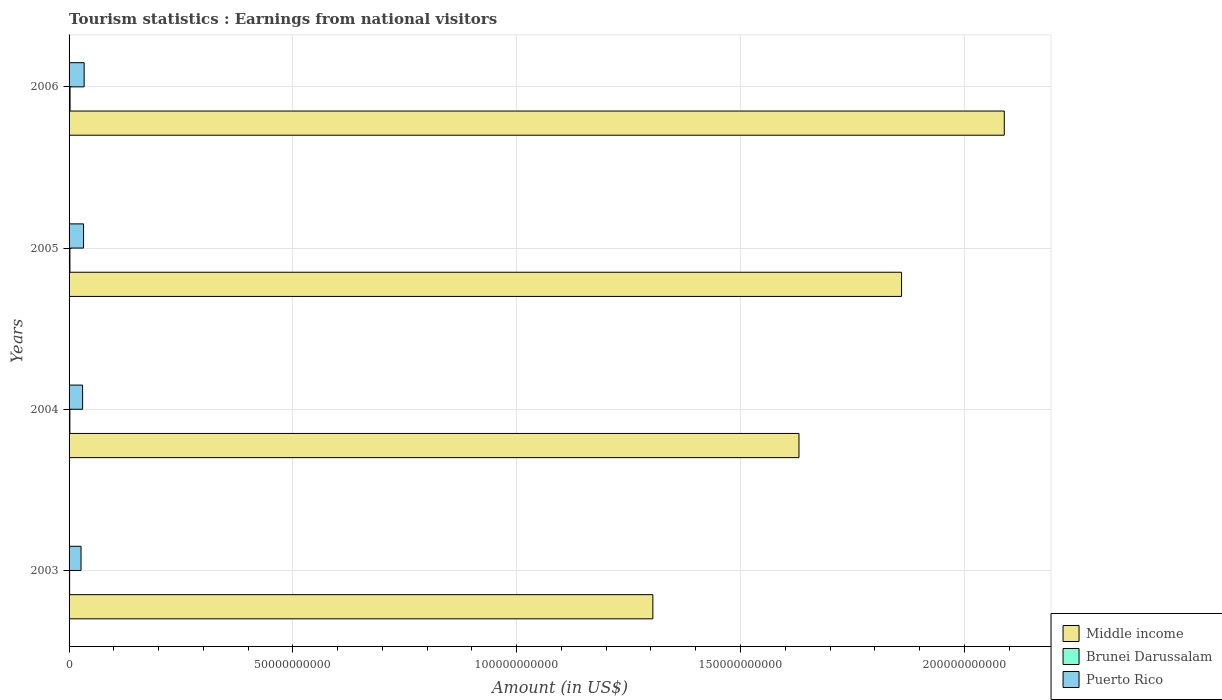How many different coloured bars are there?
Make the answer very short. 3. Are the number of bars per tick equal to the number of legend labels?
Your answer should be compact. Yes. Are the number of bars on each tick of the Y-axis equal?
Offer a terse response. Yes. What is the earnings from national visitors in Middle income in 2004?
Your response must be concise. 1.63e+11. Across all years, what is the maximum earnings from national visitors in Middle income?
Ensure brevity in your answer.  2.09e+11. Across all years, what is the minimum earnings from national visitors in Brunei Darussalam?
Give a very brief answer. 1.24e+08. What is the total earnings from national visitors in Puerto Rico in the graph?
Your answer should be very brief. 1.23e+1. What is the difference between the earnings from national visitors in Middle income in 2004 and that in 2006?
Your answer should be very brief. -4.59e+1. What is the difference between the earnings from national visitors in Puerto Rico in 2006 and the earnings from national visitors in Middle income in 2005?
Provide a succinct answer. -1.83e+11. What is the average earnings from national visitors in Brunei Darussalam per year?
Provide a succinct answer. 1.80e+08. In the year 2003, what is the difference between the earnings from national visitors in Brunei Darussalam and earnings from national visitors in Middle income?
Your answer should be very brief. -1.30e+11. In how many years, is the earnings from national visitors in Middle income greater than 160000000000 US$?
Give a very brief answer. 3. What is the ratio of the earnings from national visitors in Brunei Darussalam in 2004 to that in 2006?
Offer a very short reply. 0.81. Is the earnings from national visitors in Puerto Rico in 2003 less than that in 2005?
Give a very brief answer. Yes. What is the difference between the highest and the second highest earnings from national visitors in Puerto Rico?
Provide a short and direct response. 1.30e+08. What is the difference between the highest and the lowest earnings from national visitors in Brunei Darussalam?
Offer a terse response. 1.00e+08. In how many years, is the earnings from national visitors in Middle income greater than the average earnings from national visitors in Middle income taken over all years?
Offer a terse response. 2. Is the sum of the earnings from national visitors in Puerto Rico in 2004 and 2006 greater than the maximum earnings from national visitors in Brunei Darussalam across all years?
Provide a short and direct response. Yes. What does the 1st bar from the top in 2004 represents?
Keep it short and to the point. Puerto Rico. What does the 2nd bar from the bottom in 2003 represents?
Give a very brief answer. Brunei Darussalam. How many bars are there?
Offer a terse response. 12. Are all the bars in the graph horizontal?
Your answer should be compact. Yes. How many years are there in the graph?
Make the answer very short. 4. Are the values on the major ticks of X-axis written in scientific E-notation?
Offer a terse response. No. Does the graph contain any zero values?
Ensure brevity in your answer.  No. Does the graph contain grids?
Your answer should be compact. Yes. Where does the legend appear in the graph?
Keep it short and to the point. Bottom right. How many legend labels are there?
Your answer should be very brief. 3. How are the legend labels stacked?
Offer a terse response. Vertical. What is the title of the graph?
Give a very brief answer. Tourism statistics : Earnings from national visitors. Does "Philippines" appear as one of the legend labels in the graph?
Ensure brevity in your answer.  No. What is the label or title of the Y-axis?
Make the answer very short. Years. What is the Amount (in US$) in Middle income in 2003?
Offer a very short reply. 1.30e+11. What is the Amount (in US$) in Brunei Darussalam in 2003?
Keep it short and to the point. 1.24e+08. What is the Amount (in US$) of Puerto Rico in 2003?
Your answer should be very brief. 2.68e+09. What is the Amount (in US$) in Middle income in 2004?
Your answer should be very brief. 1.63e+11. What is the Amount (in US$) of Brunei Darussalam in 2004?
Ensure brevity in your answer.  1.81e+08. What is the Amount (in US$) in Puerto Rico in 2004?
Offer a very short reply. 3.02e+09. What is the Amount (in US$) in Middle income in 2005?
Keep it short and to the point. 1.86e+11. What is the Amount (in US$) in Brunei Darussalam in 2005?
Offer a very short reply. 1.91e+08. What is the Amount (in US$) in Puerto Rico in 2005?
Offer a terse response. 3.24e+09. What is the Amount (in US$) of Middle income in 2006?
Your response must be concise. 2.09e+11. What is the Amount (in US$) in Brunei Darussalam in 2006?
Give a very brief answer. 2.24e+08. What is the Amount (in US$) in Puerto Rico in 2006?
Offer a very short reply. 3.37e+09. Across all years, what is the maximum Amount (in US$) in Middle income?
Ensure brevity in your answer.  2.09e+11. Across all years, what is the maximum Amount (in US$) of Brunei Darussalam?
Make the answer very short. 2.24e+08. Across all years, what is the maximum Amount (in US$) of Puerto Rico?
Your answer should be very brief. 3.37e+09. Across all years, what is the minimum Amount (in US$) of Middle income?
Your answer should be compact. 1.30e+11. Across all years, what is the minimum Amount (in US$) of Brunei Darussalam?
Give a very brief answer. 1.24e+08. Across all years, what is the minimum Amount (in US$) of Puerto Rico?
Make the answer very short. 2.68e+09. What is the total Amount (in US$) of Middle income in the graph?
Your answer should be compact. 6.88e+11. What is the total Amount (in US$) in Brunei Darussalam in the graph?
Your answer should be very brief. 7.20e+08. What is the total Amount (in US$) of Puerto Rico in the graph?
Keep it short and to the point. 1.23e+1. What is the difference between the Amount (in US$) of Middle income in 2003 and that in 2004?
Provide a succinct answer. -3.26e+1. What is the difference between the Amount (in US$) of Brunei Darussalam in 2003 and that in 2004?
Offer a terse response. -5.70e+07. What is the difference between the Amount (in US$) in Puerto Rico in 2003 and that in 2004?
Offer a terse response. -3.47e+08. What is the difference between the Amount (in US$) of Middle income in 2003 and that in 2005?
Your response must be concise. -5.56e+1. What is the difference between the Amount (in US$) of Brunei Darussalam in 2003 and that in 2005?
Your answer should be compact. -6.70e+07. What is the difference between the Amount (in US$) of Puerto Rico in 2003 and that in 2005?
Keep it short and to the point. -5.62e+08. What is the difference between the Amount (in US$) of Middle income in 2003 and that in 2006?
Provide a succinct answer. -7.85e+1. What is the difference between the Amount (in US$) of Brunei Darussalam in 2003 and that in 2006?
Ensure brevity in your answer.  -1.00e+08. What is the difference between the Amount (in US$) in Puerto Rico in 2003 and that in 2006?
Offer a terse response. -6.92e+08. What is the difference between the Amount (in US$) in Middle income in 2004 and that in 2005?
Offer a terse response. -2.29e+1. What is the difference between the Amount (in US$) of Brunei Darussalam in 2004 and that in 2005?
Your response must be concise. -1.00e+07. What is the difference between the Amount (in US$) of Puerto Rico in 2004 and that in 2005?
Keep it short and to the point. -2.15e+08. What is the difference between the Amount (in US$) of Middle income in 2004 and that in 2006?
Make the answer very short. -4.59e+1. What is the difference between the Amount (in US$) of Brunei Darussalam in 2004 and that in 2006?
Your answer should be compact. -4.30e+07. What is the difference between the Amount (in US$) in Puerto Rico in 2004 and that in 2006?
Give a very brief answer. -3.45e+08. What is the difference between the Amount (in US$) of Middle income in 2005 and that in 2006?
Make the answer very short. -2.29e+1. What is the difference between the Amount (in US$) in Brunei Darussalam in 2005 and that in 2006?
Keep it short and to the point. -3.30e+07. What is the difference between the Amount (in US$) of Puerto Rico in 2005 and that in 2006?
Keep it short and to the point. -1.30e+08. What is the difference between the Amount (in US$) of Middle income in 2003 and the Amount (in US$) of Brunei Darussalam in 2004?
Provide a short and direct response. 1.30e+11. What is the difference between the Amount (in US$) in Middle income in 2003 and the Amount (in US$) in Puerto Rico in 2004?
Your answer should be very brief. 1.27e+11. What is the difference between the Amount (in US$) in Brunei Darussalam in 2003 and the Amount (in US$) in Puerto Rico in 2004?
Your answer should be compact. -2.90e+09. What is the difference between the Amount (in US$) in Middle income in 2003 and the Amount (in US$) in Brunei Darussalam in 2005?
Offer a terse response. 1.30e+11. What is the difference between the Amount (in US$) in Middle income in 2003 and the Amount (in US$) in Puerto Rico in 2005?
Provide a short and direct response. 1.27e+11. What is the difference between the Amount (in US$) of Brunei Darussalam in 2003 and the Amount (in US$) of Puerto Rico in 2005?
Give a very brief answer. -3.12e+09. What is the difference between the Amount (in US$) of Middle income in 2003 and the Amount (in US$) of Brunei Darussalam in 2006?
Ensure brevity in your answer.  1.30e+11. What is the difference between the Amount (in US$) in Middle income in 2003 and the Amount (in US$) in Puerto Rico in 2006?
Provide a short and direct response. 1.27e+11. What is the difference between the Amount (in US$) of Brunei Darussalam in 2003 and the Amount (in US$) of Puerto Rico in 2006?
Ensure brevity in your answer.  -3.24e+09. What is the difference between the Amount (in US$) in Middle income in 2004 and the Amount (in US$) in Brunei Darussalam in 2005?
Keep it short and to the point. 1.63e+11. What is the difference between the Amount (in US$) of Middle income in 2004 and the Amount (in US$) of Puerto Rico in 2005?
Offer a very short reply. 1.60e+11. What is the difference between the Amount (in US$) of Brunei Darussalam in 2004 and the Amount (in US$) of Puerto Rico in 2005?
Provide a succinct answer. -3.06e+09. What is the difference between the Amount (in US$) of Middle income in 2004 and the Amount (in US$) of Brunei Darussalam in 2006?
Your response must be concise. 1.63e+11. What is the difference between the Amount (in US$) in Middle income in 2004 and the Amount (in US$) in Puerto Rico in 2006?
Provide a short and direct response. 1.60e+11. What is the difference between the Amount (in US$) in Brunei Darussalam in 2004 and the Amount (in US$) in Puerto Rico in 2006?
Provide a succinct answer. -3.19e+09. What is the difference between the Amount (in US$) of Middle income in 2005 and the Amount (in US$) of Brunei Darussalam in 2006?
Offer a terse response. 1.86e+11. What is the difference between the Amount (in US$) of Middle income in 2005 and the Amount (in US$) of Puerto Rico in 2006?
Ensure brevity in your answer.  1.83e+11. What is the difference between the Amount (in US$) of Brunei Darussalam in 2005 and the Amount (in US$) of Puerto Rico in 2006?
Your response must be concise. -3.18e+09. What is the average Amount (in US$) in Middle income per year?
Ensure brevity in your answer.  1.72e+11. What is the average Amount (in US$) in Brunei Darussalam per year?
Offer a very short reply. 1.80e+08. What is the average Amount (in US$) of Puerto Rico per year?
Keep it short and to the point. 3.08e+09. In the year 2003, what is the difference between the Amount (in US$) of Middle income and Amount (in US$) of Brunei Darussalam?
Offer a terse response. 1.30e+11. In the year 2003, what is the difference between the Amount (in US$) of Middle income and Amount (in US$) of Puerto Rico?
Give a very brief answer. 1.28e+11. In the year 2003, what is the difference between the Amount (in US$) of Brunei Darussalam and Amount (in US$) of Puerto Rico?
Your response must be concise. -2.55e+09. In the year 2004, what is the difference between the Amount (in US$) in Middle income and Amount (in US$) in Brunei Darussalam?
Your response must be concise. 1.63e+11. In the year 2004, what is the difference between the Amount (in US$) in Middle income and Amount (in US$) in Puerto Rico?
Make the answer very short. 1.60e+11. In the year 2004, what is the difference between the Amount (in US$) in Brunei Darussalam and Amount (in US$) in Puerto Rico?
Keep it short and to the point. -2.84e+09. In the year 2005, what is the difference between the Amount (in US$) of Middle income and Amount (in US$) of Brunei Darussalam?
Keep it short and to the point. 1.86e+11. In the year 2005, what is the difference between the Amount (in US$) in Middle income and Amount (in US$) in Puerto Rico?
Your response must be concise. 1.83e+11. In the year 2005, what is the difference between the Amount (in US$) in Brunei Darussalam and Amount (in US$) in Puerto Rico?
Provide a short and direct response. -3.05e+09. In the year 2006, what is the difference between the Amount (in US$) in Middle income and Amount (in US$) in Brunei Darussalam?
Your answer should be very brief. 2.09e+11. In the year 2006, what is the difference between the Amount (in US$) in Middle income and Amount (in US$) in Puerto Rico?
Your answer should be very brief. 2.06e+11. In the year 2006, what is the difference between the Amount (in US$) in Brunei Darussalam and Amount (in US$) in Puerto Rico?
Give a very brief answer. -3.14e+09. What is the ratio of the Amount (in US$) of Middle income in 2003 to that in 2004?
Ensure brevity in your answer.  0.8. What is the ratio of the Amount (in US$) of Brunei Darussalam in 2003 to that in 2004?
Your response must be concise. 0.69. What is the ratio of the Amount (in US$) in Puerto Rico in 2003 to that in 2004?
Your answer should be compact. 0.89. What is the ratio of the Amount (in US$) of Middle income in 2003 to that in 2005?
Offer a terse response. 0.7. What is the ratio of the Amount (in US$) of Brunei Darussalam in 2003 to that in 2005?
Provide a short and direct response. 0.65. What is the ratio of the Amount (in US$) in Puerto Rico in 2003 to that in 2005?
Keep it short and to the point. 0.83. What is the ratio of the Amount (in US$) in Middle income in 2003 to that in 2006?
Ensure brevity in your answer.  0.62. What is the ratio of the Amount (in US$) of Brunei Darussalam in 2003 to that in 2006?
Make the answer very short. 0.55. What is the ratio of the Amount (in US$) of Puerto Rico in 2003 to that in 2006?
Offer a very short reply. 0.79. What is the ratio of the Amount (in US$) in Middle income in 2004 to that in 2005?
Your response must be concise. 0.88. What is the ratio of the Amount (in US$) of Brunei Darussalam in 2004 to that in 2005?
Give a very brief answer. 0.95. What is the ratio of the Amount (in US$) of Puerto Rico in 2004 to that in 2005?
Give a very brief answer. 0.93. What is the ratio of the Amount (in US$) of Middle income in 2004 to that in 2006?
Ensure brevity in your answer.  0.78. What is the ratio of the Amount (in US$) in Brunei Darussalam in 2004 to that in 2006?
Offer a very short reply. 0.81. What is the ratio of the Amount (in US$) of Puerto Rico in 2004 to that in 2006?
Provide a succinct answer. 0.9. What is the ratio of the Amount (in US$) in Middle income in 2005 to that in 2006?
Provide a succinct answer. 0.89. What is the ratio of the Amount (in US$) of Brunei Darussalam in 2005 to that in 2006?
Make the answer very short. 0.85. What is the ratio of the Amount (in US$) in Puerto Rico in 2005 to that in 2006?
Your response must be concise. 0.96. What is the difference between the highest and the second highest Amount (in US$) of Middle income?
Keep it short and to the point. 2.29e+1. What is the difference between the highest and the second highest Amount (in US$) in Brunei Darussalam?
Offer a terse response. 3.30e+07. What is the difference between the highest and the second highest Amount (in US$) of Puerto Rico?
Make the answer very short. 1.30e+08. What is the difference between the highest and the lowest Amount (in US$) of Middle income?
Give a very brief answer. 7.85e+1. What is the difference between the highest and the lowest Amount (in US$) in Puerto Rico?
Provide a succinct answer. 6.92e+08. 